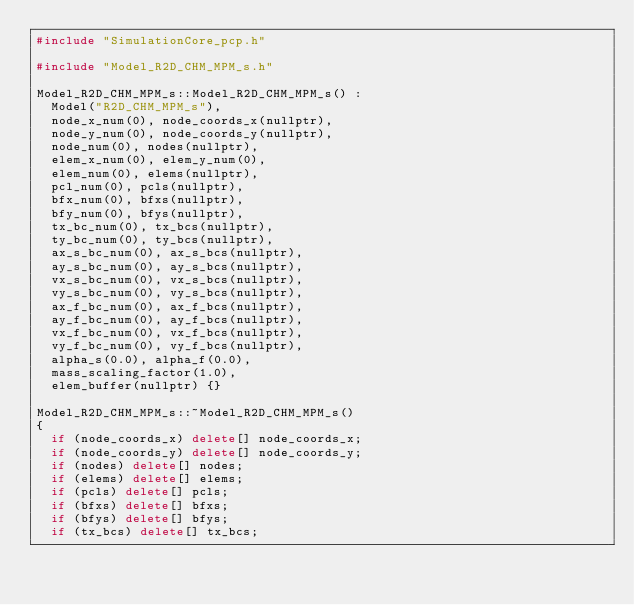Convert code to text. <code><loc_0><loc_0><loc_500><loc_500><_C++_>#include "SimulationCore_pcp.h"

#include "Model_R2D_CHM_MPM_s.h"

Model_R2D_CHM_MPM_s::Model_R2D_CHM_MPM_s() :
	Model("R2D_CHM_MPM_s"),
	node_x_num(0), node_coords_x(nullptr),
	node_y_num(0), node_coords_y(nullptr),
	node_num(0), nodes(nullptr),
	elem_x_num(0), elem_y_num(0),
	elem_num(0), elems(nullptr),
	pcl_num(0), pcls(nullptr),
	bfx_num(0), bfxs(nullptr),
	bfy_num(0), bfys(nullptr),
	tx_bc_num(0), tx_bcs(nullptr),
	ty_bc_num(0), ty_bcs(nullptr),
	ax_s_bc_num(0), ax_s_bcs(nullptr),
	ay_s_bc_num(0), ay_s_bcs(nullptr),
	vx_s_bc_num(0), vx_s_bcs(nullptr),
	vy_s_bc_num(0), vy_s_bcs(nullptr),
	ax_f_bc_num(0), ax_f_bcs(nullptr),
	ay_f_bc_num(0), ay_f_bcs(nullptr),
	vx_f_bc_num(0), vx_f_bcs(nullptr),
	vy_f_bc_num(0), vy_f_bcs(nullptr),
	alpha_s(0.0), alpha_f(0.0),
	mass_scaling_factor(1.0),
	elem_buffer(nullptr) {}

Model_R2D_CHM_MPM_s::~Model_R2D_CHM_MPM_s()
{
	if (node_coords_x) delete[] node_coords_x;
	if (node_coords_y) delete[] node_coords_y;
	if (nodes) delete[] nodes;
	if (elems) delete[] elems;
	if (pcls) delete[] pcls;
	if (bfxs) delete[] bfxs;
	if (bfys) delete[] bfys;
	if (tx_bcs) delete[] tx_bcs;</code> 